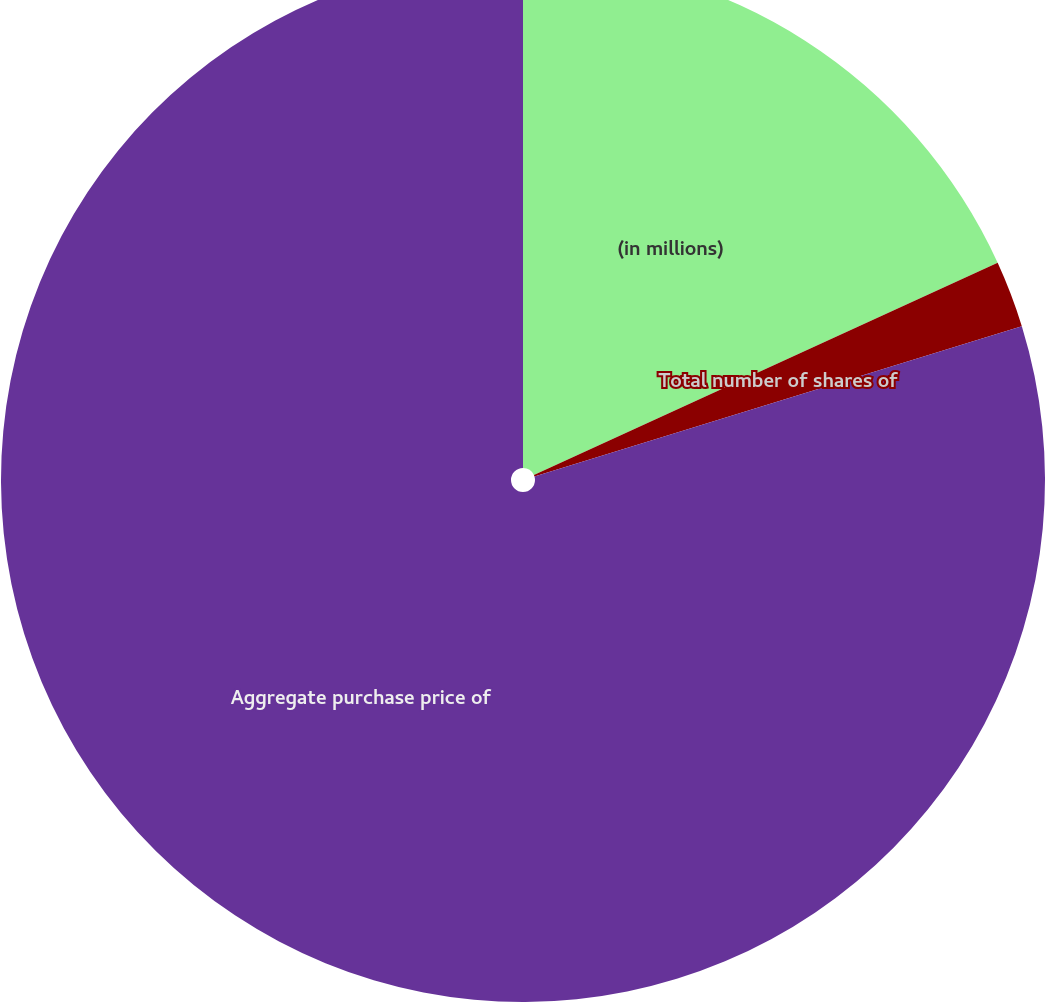Convert chart. <chart><loc_0><loc_0><loc_500><loc_500><pie_chart><fcel>(in millions)<fcel>Total number of shares of<fcel>Aggregate purchase price of<nl><fcel>18.17%<fcel>2.07%<fcel>79.76%<nl></chart> 